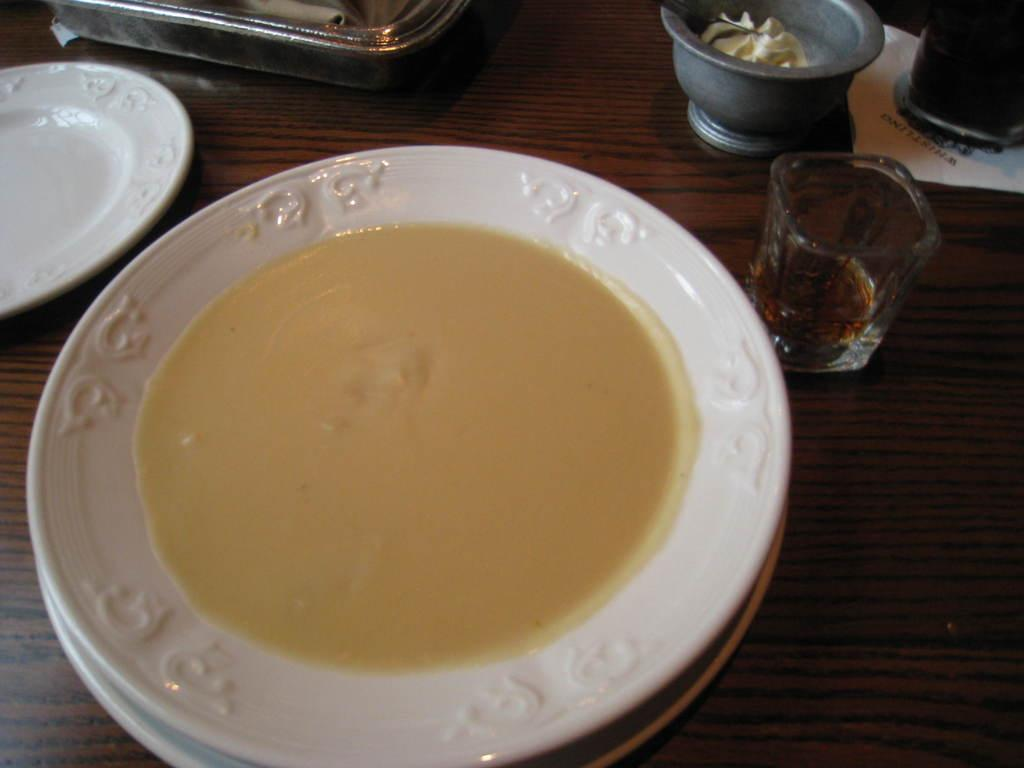What type of furniture is present in the image? There is a table in the image. What is placed on the table? There is a serving plate with sauce, a glass tumbler with a beverage, and a bowl with cream on the table. Can you describe the contents of the glass tumbler? The glass tumbler contains a beverage. What is the consistency of the contents in the bowl? The bowl contains cream. What type of star is visible in the image? There is no star visible in the image; it only features a table with various items on it. 